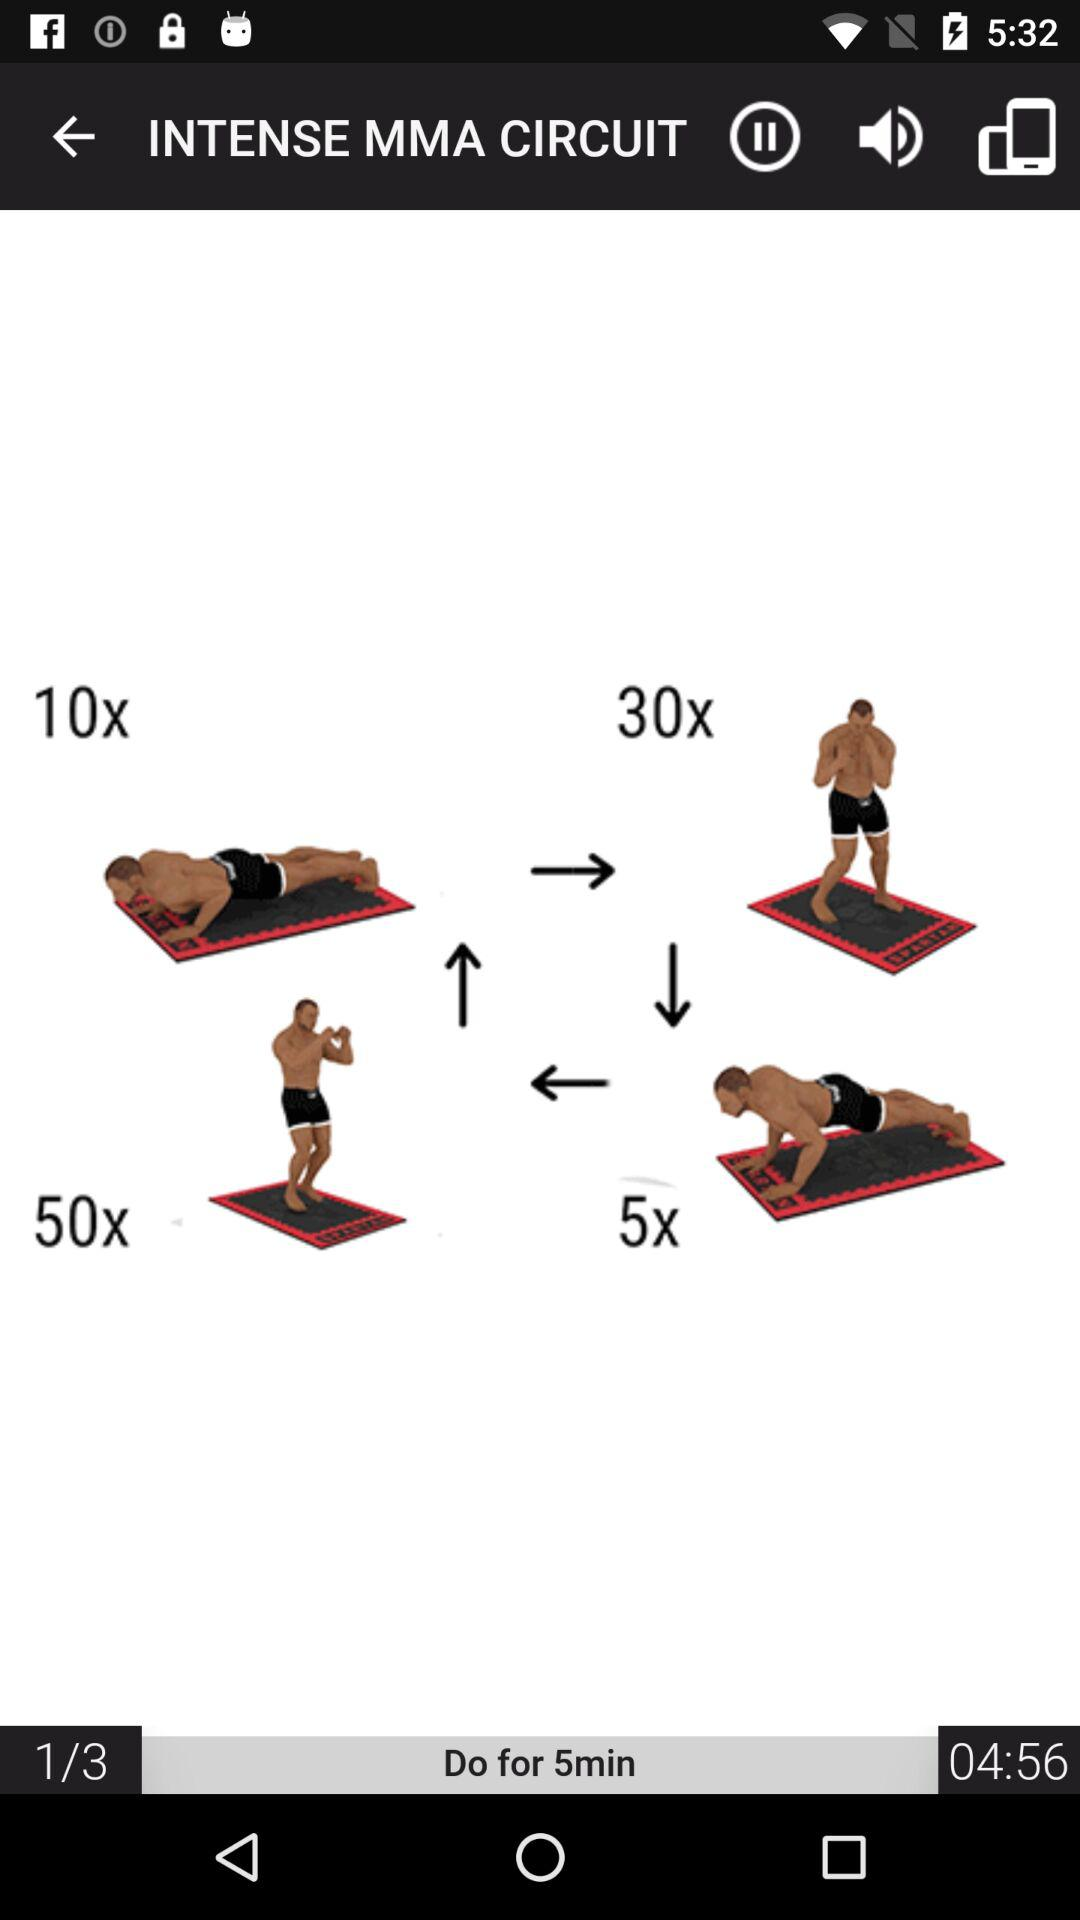What is the duration of the workout? The duration of the workout is 5 minutes. 